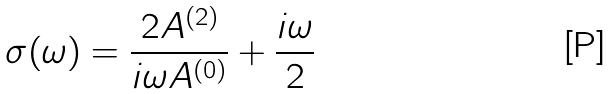Convert formula to latex. <formula><loc_0><loc_0><loc_500><loc_500>\sigma ( \omega ) = \frac { 2 A ^ { ( 2 ) } } { i \omega A ^ { ( 0 ) } } + \frac { i \omega } { 2 }</formula> 